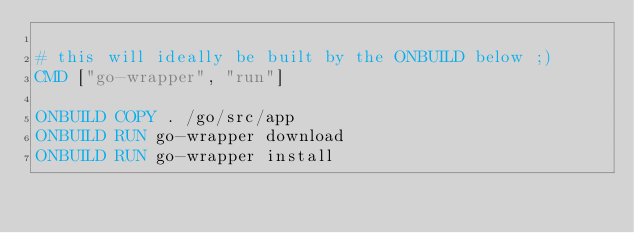<code> <loc_0><loc_0><loc_500><loc_500><_Dockerfile_>
# this will ideally be built by the ONBUILD below ;)
CMD ["go-wrapper", "run"]

ONBUILD COPY . /go/src/app
ONBUILD RUN go-wrapper download
ONBUILD RUN go-wrapper install
</code> 